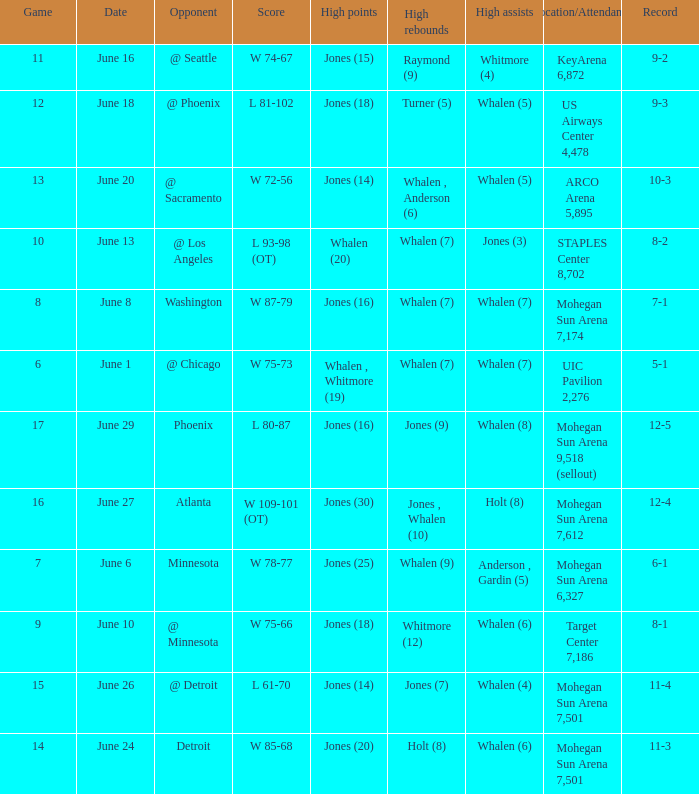What is the location/attendance when the record is 9-2? KeyArena 6,872. 